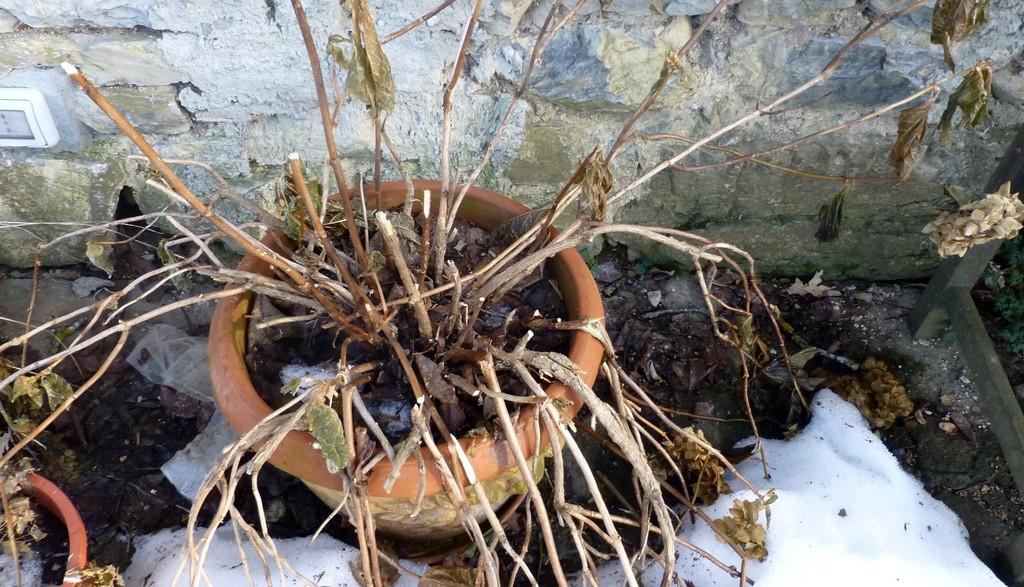What type of plant is in the pot in the image? The fact does not specify the type of plant, only that there is a plant in a pot. How many pots with plants are visible in the image? There are two pots with plants visible in the image. What is the condition of the ground in the image? The ground appears to be covered in snow in the image. What can be seen in the background of the image? There is a wall visible in the background of the image. What type of wood is used to make the balls in the image? There are no balls or wood present in the image. 